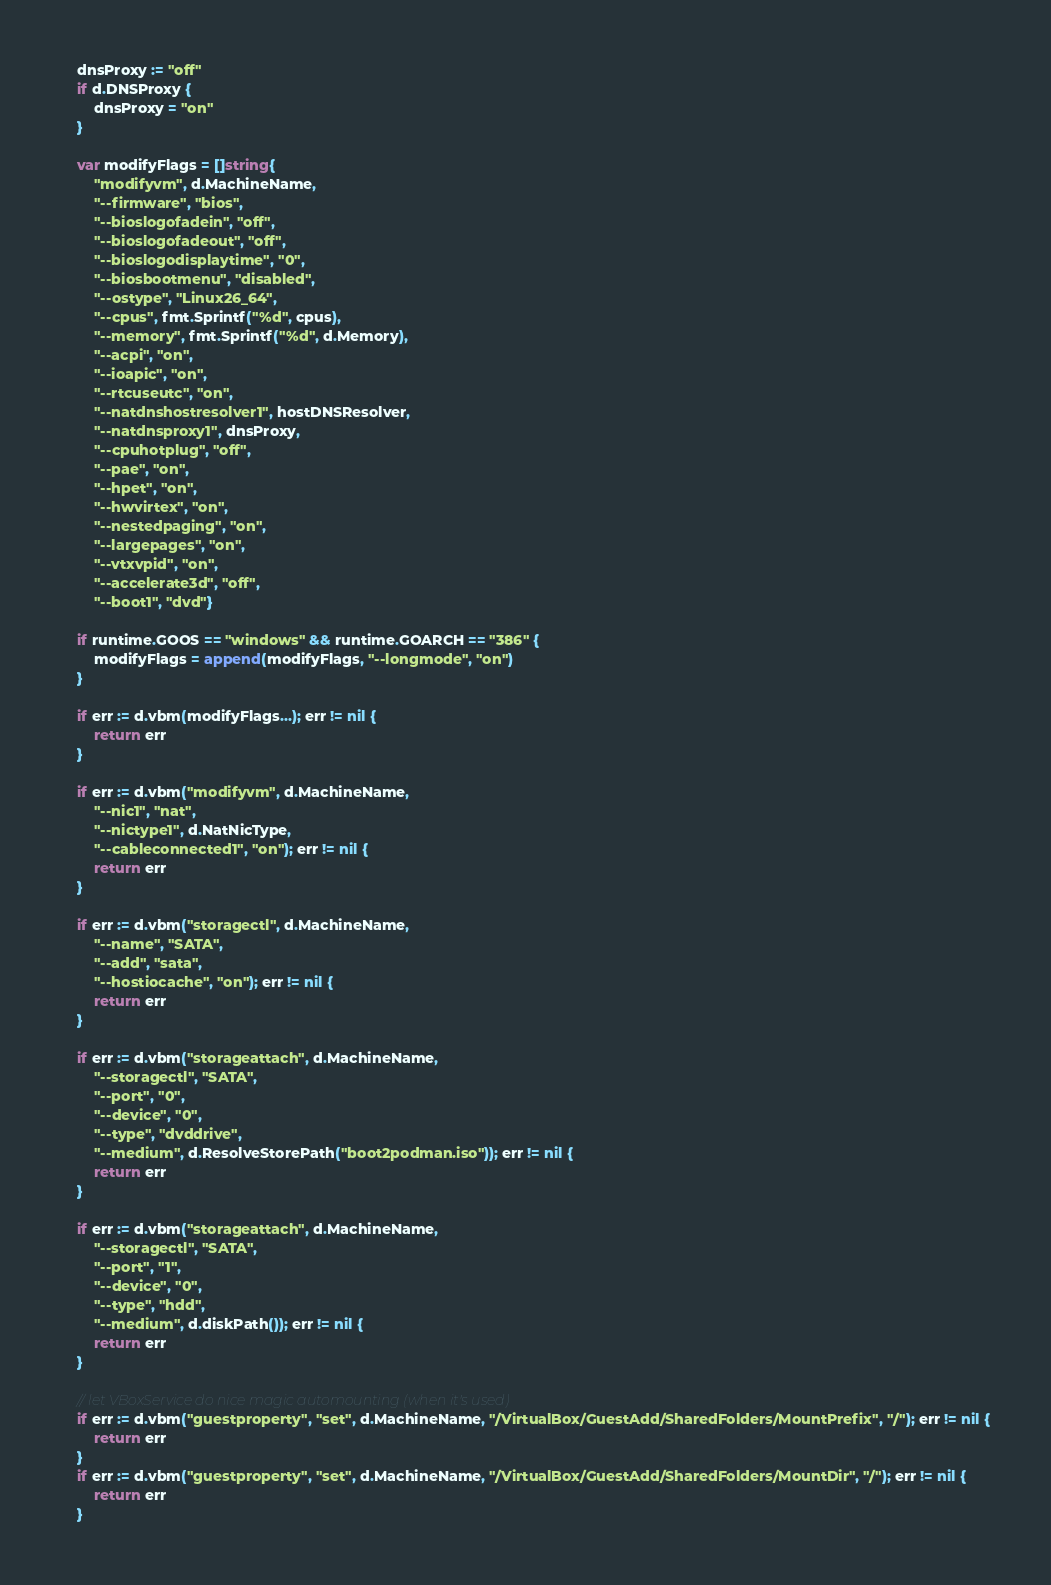<code> <loc_0><loc_0><loc_500><loc_500><_Go_>	dnsProxy := "off"
	if d.DNSProxy {
		dnsProxy = "on"
	}

	var modifyFlags = []string{
		"modifyvm", d.MachineName,
		"--firmware", "bios",
		"--bioslogofadein", "off",
		"--bioslogofadeout", "off",
		"--bioslogodisplaytime", "0",
		"--biosbootmenu", "disabled",
		"--ostype", "Linux26_64",
		"--cpus", fmt.Sprintf("%d", cpus),
		"--memory", fmt.Sprintf("%d", d.Memory),
		"--acpi", "on",
		"--ioapic", "on",
		"--rtcuseutc", "on",
		"--natdnshostresolver1", hostDNSResolver,
		"--natdnsproxy1", dnsProxy,
		"--cpuhotplug", "off",
		"--pae", "on",
		"--hpet", "on",
		"--hwvirtex", "on",
		"--nestedpaging", "on",
		"--largepages", "on",
		"--vtxvpid", "on",
		"--accelerate3d", "off",
		"--boot1", "dvd"}

	if runtime.GOOS == "windows" && runtime.GOARCH == "386" {
		modifyFlags = append(modifyFlags, "--longmode", "on")
	}

	if err := d.vbm(modifyFlags...); err != nil {
		return err
	}

	if err := d.vbm("modifyvm", d.MachineName,
		"--nic1", "nat",
		"--nictype1", d.NatNicType,
		"--cableconnected1", "on"); err != nil {
		return err
	}

	if err := d.vbm("storagectl", d.MachineName,
		"--name", "SATA",
		"--add", "sata",
		"--hostiocache", "on"); err != nil {
		return err
	}

	if err := d.vbm("storageattach", d.MachineName,
		"--storagectl", "SATA",
		"--port", "0",
		"--device", "0",
		"--type", "dvddrive",
		"--medium", d.ResolveStorePath("boot2podman.iso")); err != nil {
		return err
	}

	if err := d.vbm("storageattach", d.MachineName,
		"--storagectl", "SATA",
		"--port", "1",
		"--device", "0",
		"--type", "hdd",
		"--medium", d.diskPath()); err != nil {
		return err
	}

	// let VBoxService do nice magic automounting (when it's used)
	if err := d.vbm("guestproperty", "set", d.MachineName, "/VirtualBox/GuestAdd/SharedFolders/MountPrefix", "/"); err != nil {
		return err
	}
	if err := d.vbm("guestproperty", "set", d.MachineName, "/VirtualBox/GuestAdd/SharedFolders/MountDir", "/"); err != nil {
		return err
	}
</code> 